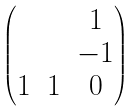Convert formula to latex. <formula><loc_0><loc_0><loc_500><loc_500>\begin{pmatrix} & & 1 \\ & & - 1 \\ 1 & 1 & 0 \end{pmatrix}</formula> 